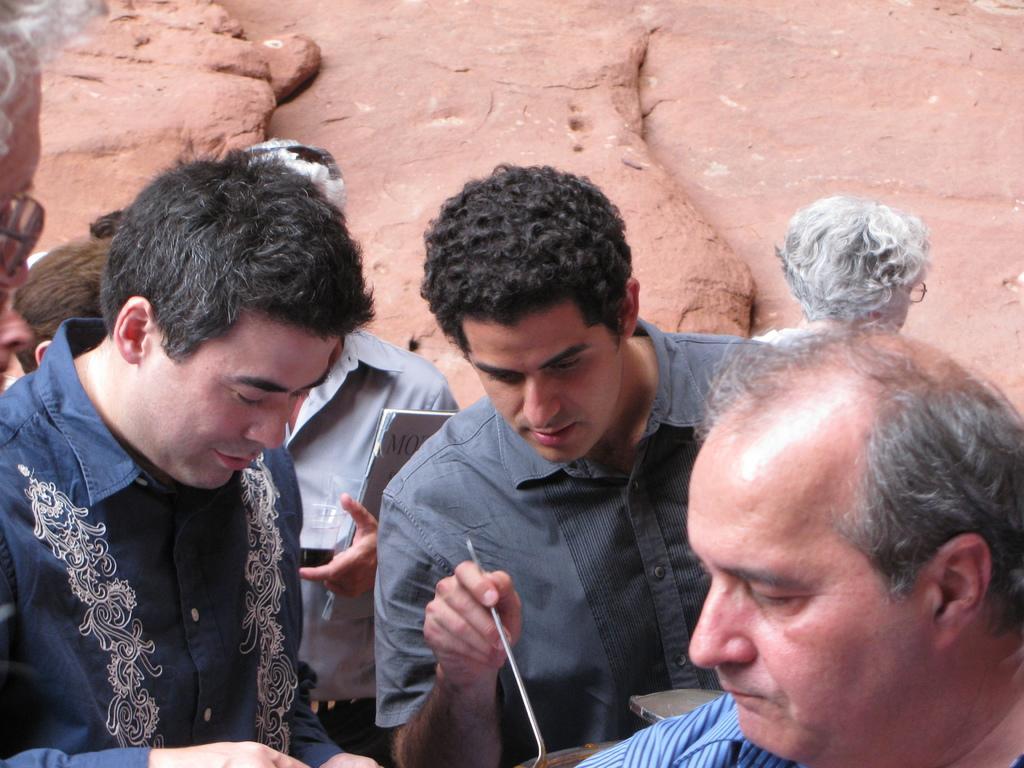Can you describe this image briefly? In this picture I can see few people are standing and I can see a man holding a glass and a book and I can see another man holding a serving spoon and looks like a rock in the background. 